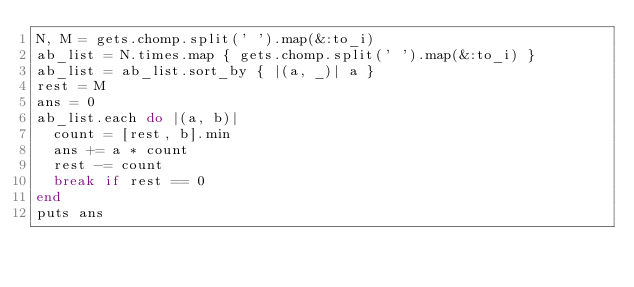<code> <loc_0><loc_0><loc_500><loc_500><_Ruby_>N, M = gets.chomp.split(' ').map(&:to_i)
ab_list = N.times.map { gets.chomp.split(' ').map(&:to_i) }
ab_list = ab_list.sort_by { |(a, _)| a }
rest = M
ans = 0
ab_list.each do |(a, b)|
  count = [rest, b].min
  ans += a * count
  rest -= count
  break if rest == 0
end
puts ans
</code> 